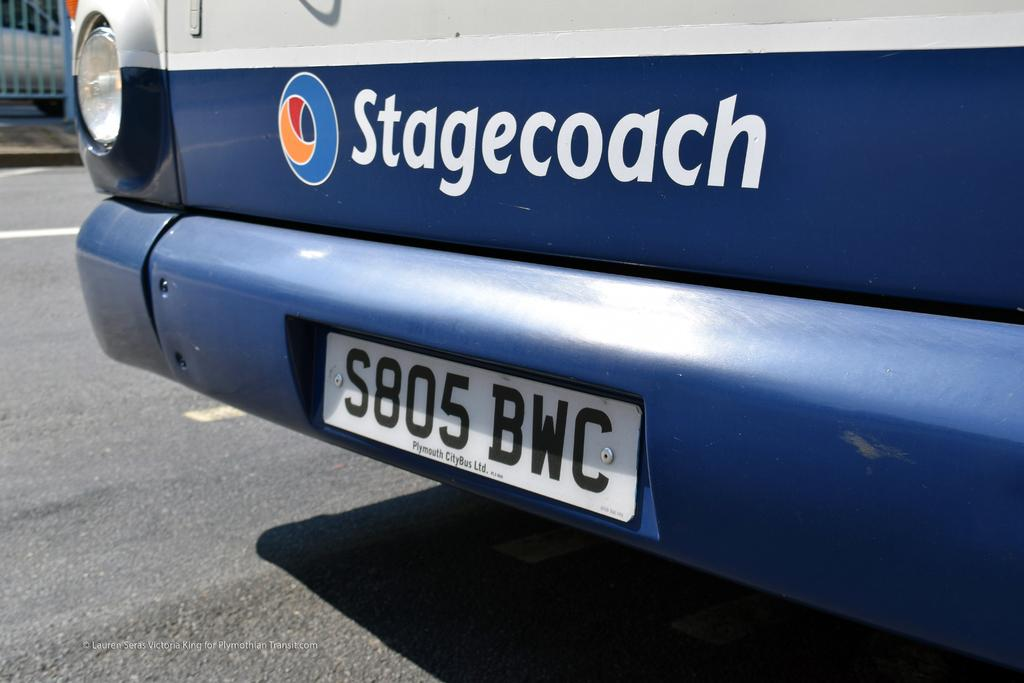<image>
Create a compact narrative representing the image presented. Blue vehicle with the word Stagecoach near the bottom. 